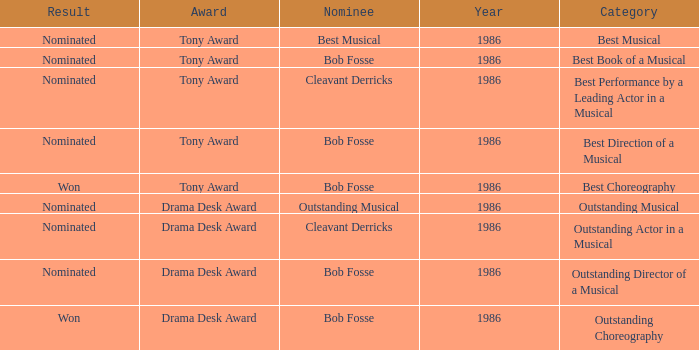Which award has the category of the best direction of a musical? Tony Award. 